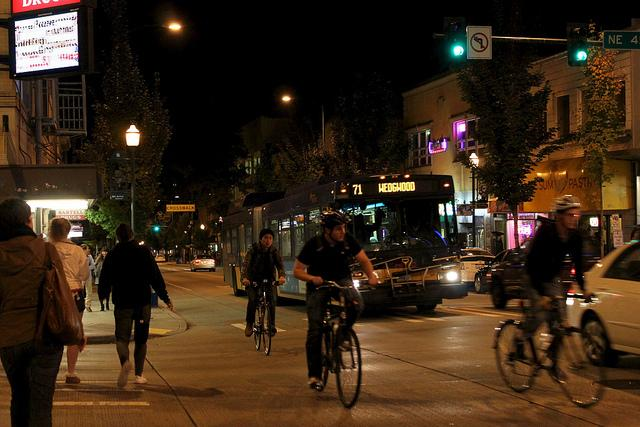What does the sign beside the green light forbid? Please explain your reasoning. left turns. The sign beside the green streetlight has a left turn picture with a red cross out mark over it. 